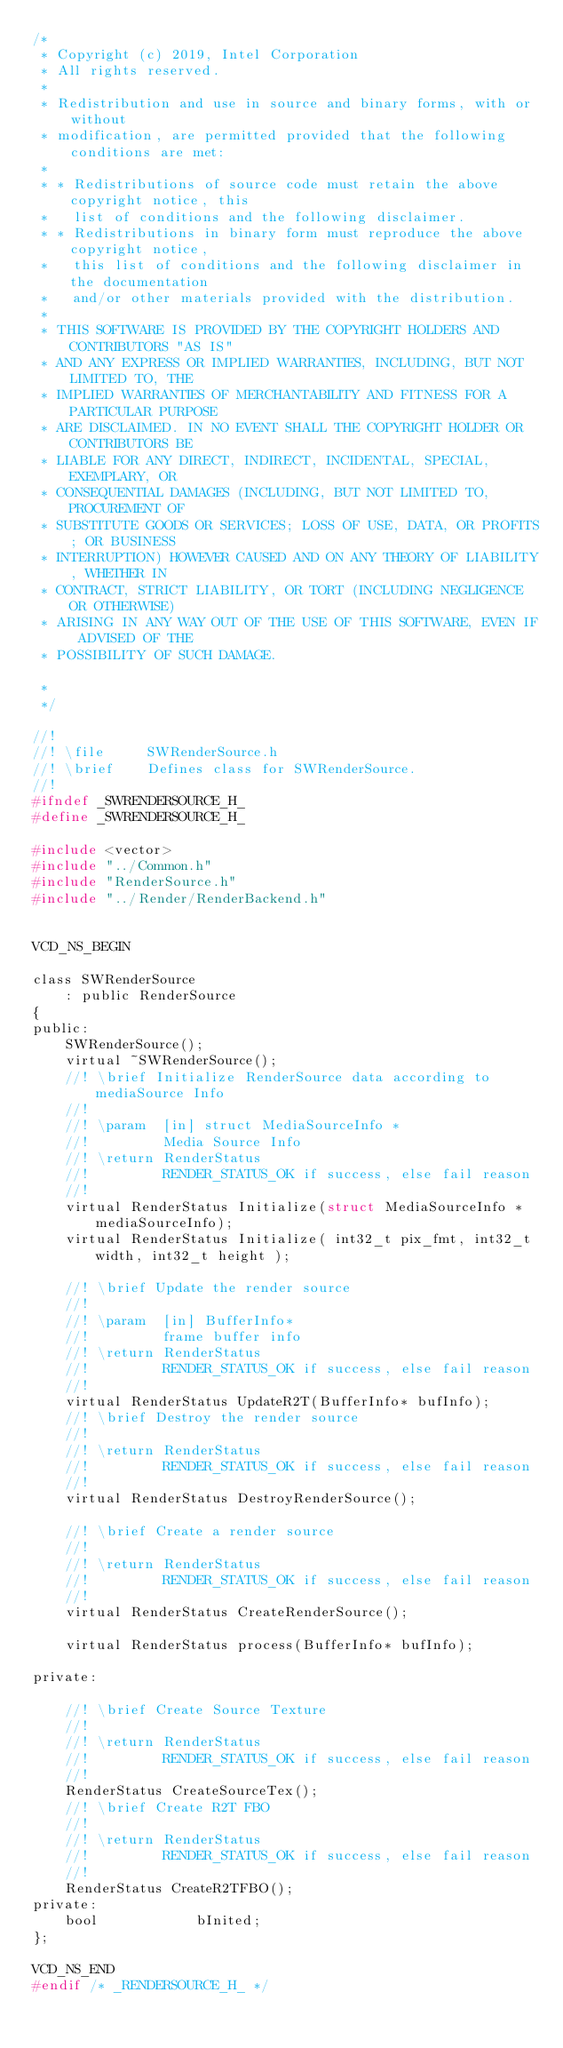Convert code to text. <code><loc_0><loc_0><loc_500><loc_500><_C_>/*
 * Copyright (c) 2019, Intel Corporation
 * All rights reserved.
 *
 * Redistribution and use in source and binary forms, with or without
 * modification, are permitted provided that the following conditions are met:
 *
 * * Redistributions of source code must retain the above copyright notice, this
 *   list of conditions and the following disclaimer.
 * * Redistributions in binary form must reproduce the above copyright notice,
 *   this list of conditions and the following disclaimer in the documentation
 *   and/or other materials provided with the distribution.
 *
 * THIS SOFTWARE IS PROVIDED BY THE COPYRIGHT HOLDERS AND CONTRIBUTORS "AS IS"
 * AND ANY EXPRESS OR IMPLIED WARRANTIES, INCLUDING, BUT NOT LIMITED TO, THE
 * IMPLIED WARRANTIES OF MERCHANTABILITY AND FITNESS FOR A PARTICULAR PURPOSE
 * ARE DISCLAIMED. IN NO EVENT SHALL THE COPYRIGHT HOLDER OR CONTRIBUTORS BE
 * LIABLE FOR ANY DIRECT, INDIRECT, INCIDENTAL, SPECIAL, EXEMPLARY, OR
 * CONSEQUENTIAL DAMAGES (INCLUDING, BUT NOT LIMITED TO, PROCUREMENT OF
 * SUBSTITUTE GOODS OR SERVICES; LOSS OF USE, DATA, OR PROFITS; OR BUSINESS
 * INTERRUPTION) HOWEVER CAUSED AND ON ANY THEORY OF LIABILITY, WHETHER IN
 * CONTRACT, STRICT LIABILITY, OR TORT (INCLUDING NEGLIGENCE OR OTHERWISE)
 * ARISING IN ANY WAY OUT OF THE USE OF THIS SOFTWARE, EVEN IF ADVISED OF THE
 * POSSIBILITY OF SUCH DAMAGE.

 *
 */

//!
//! \file     SWRenderSource.h
//! \brief    Defines class for SWRenderSource.
//!
#ifndef _SWRENDERSOURCE_H_
#define _SWRENDERSOURCE_H_

#include <vector>
#include "../Common.h"
#include "RenderSource.h"
#include "../Render/RenderBackend.h"


VCD_NS_BEGIN

class SWRenderSource
    : public RenderSource
{
public:
    SWRenderSource();
    virtual ~SWRenderSource();
    //! \brief Initialize RenderSource data according to mediaSource Info
    //!
    //! \param  [in] struct MediaSourceInfo *
    //!         Media Source Info
    //! \return RenderStatus
    //!         RENDER_STATUS_OK if success, else fail reason
    //!
    virtual RenderStatus Initialize(struct MediaSourceInfo *mediaSourceInfo);
    virtual RenderStatus Initialize( int32_t pix_fmt, int32_t width, int32_t height );

    //! \brief Update the render source
    //!
    //! \param  [in] BufferInfo*
    //!         frame buffer info
    //! \return RenderStatus
    //!         RENDER_STATUS_OK if success, else fail reason
    //!
    virtual RenderStatus UpdateR2T(BufferInfo* bufInfo);
    //! \brief Destroy the render source
    //!
    //! \return RenderStatus
    //!         RENDER_STATUS_OK if success, else fail reason
    //!
    virtual RenderStatus DestroyRenderSource();

    //! \brief Create a render source
    //!
    //! \return RenderStatus
    //!         RENDER_STATUS_OK if success, else fail reason
    //!
    virtual RenderStatus CreateRenderSource();

    virtual RenderStatus process(BufferInfo* bufInfo);

private:

    //! \brief Create Source Texture
    //!
    //! \return RenderStatus
    //!         RENDER_STATUS_OK if success, else fail reason
    //!
    RenderStatus CreateSourceTex();
    //! \brief Create R2T FBO
    //!
    //! \return RenderStatus
    //!         RENDER_STATUS_OK if success, else fail reason
    //!
    RenderStatus CreateR2TFBO();
private:
    bool            bInited;
};

VCD_NS_END
#endif /* _RENDERSOURCE_H_ */
</code> 